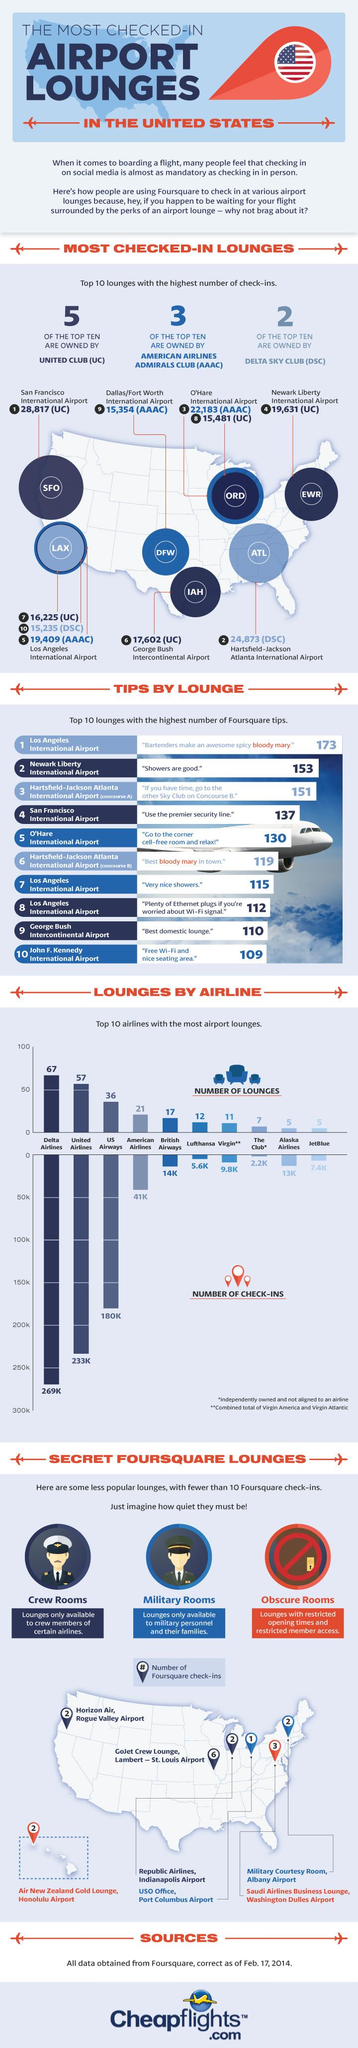Draw attention to some important aspects in this diagram. Delta Airlines boasts the greatest number of lounges among all airlines. There have been a total of 247,000 check-ins for both United Airlines and British Airways. Alaska Airlines and JetBlue both have 10 lounges. The entity that owns the maximum number of the top 10 most checked-in lounges is United Club (UC). 